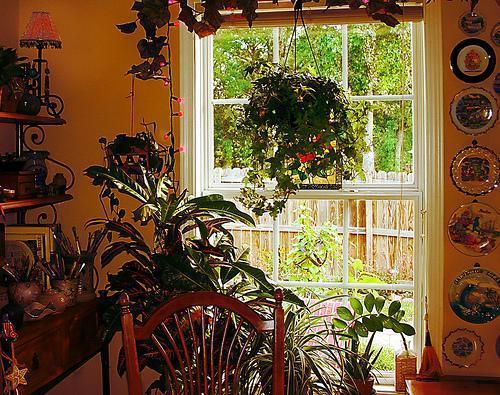How many windows are shown?
Give a very brief answer. 1. 